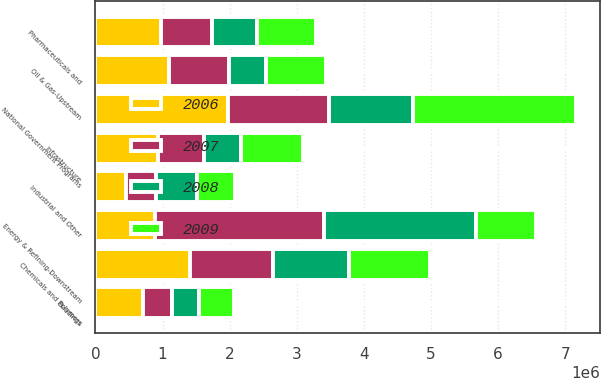Convert chart to OTSL. <chart><loc_0><loc_0><loc_500><loc_500><stacked_bar_chart><ecel><fcel>Energy & Refining-Downstream<fcel>National Government Programs<fcel>Chemicals and Polymers<fcel>Infrastructure<fcel>Oil & Gas-Upstream<fcel>Pharmaceuticals and<fcel>Buildings<fcel>Industrial and Other<nl><fcel>2009<fcel>893114<fcel>2.42462e+06<fcel>1.21003e+06<fcel>933519<fcel>895284<fcel>875007<fcel>517085<fcel>564041<nl><fcel>2006<fcel>893114<fcel>1.97618e+06<fcel>1.40987e+06<fcel>935333<fcel>1.10274e+06<fcel>978867<fcel>708081<fcel>453285<nl><fcel>2007<fcel>2.52006e+06<fcel>1.50001e+06<fcel>1.23835e+06<fcel>681367<fcel>890943<fcel>756178<fcel>437122<fcel>449939<nl><fcel>2008<fcel>2.25593e+06<fcel>1.25936e+06<fcel>1.12425e+06<fcel>546999<fcel>546663<fcel>678989<fcel>395190<fcel>613886<nl></chart> 